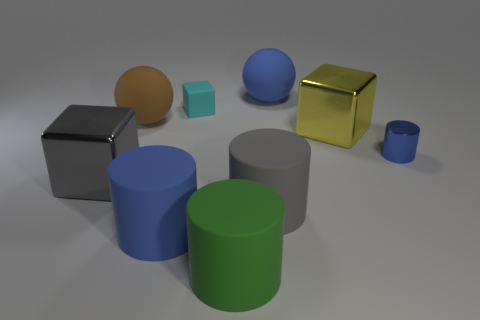Are the big blue thing in front of the shiny cylinder and the large gray block made of the same material?
Your response must be concise. No. Is there a sphere right of the blue thing left of the green rubber thing?
Keep it short and to the point. Yes. There is another small object that is the same shape as the yellow thing; what is its material?
Your response must be concise. Rubber. Is the number of large blue things that are on the right side of the big yellow thing greater than the number of blue balls that are in front of the blue matte cylinder?
Give a very brief answer. No. There is a green thing that is made of the same material as the tiny cyan object; what shape is it?
Your answer should be compact. Cylinder. Are there more big yellow objects that are on the left side of the green object than metallic cubes?
Your response must be concise. No. How many matte cylinders are the same color as the small metallic cylinder?
Your answer should be compact. 1. How many other objects are the same color as the small matte cube?
Provide a short and direct response. 0. Are there more brown things than big brown metal things?
Keep it short and to the point. Yes. What is the cyan block made of?
Give a very brief answer. Rubber. 